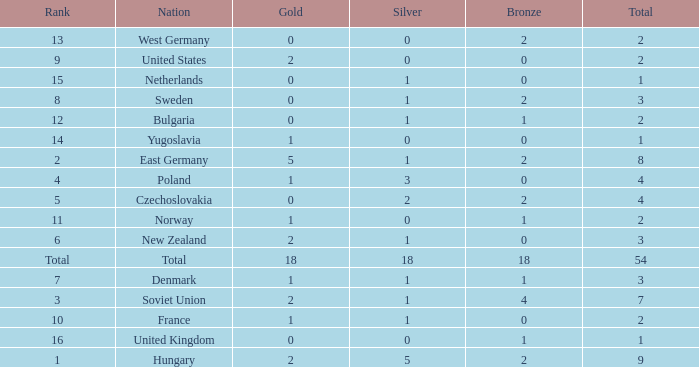What is the lowest total for those receiving less than 18 but more than 14? 1.0. 